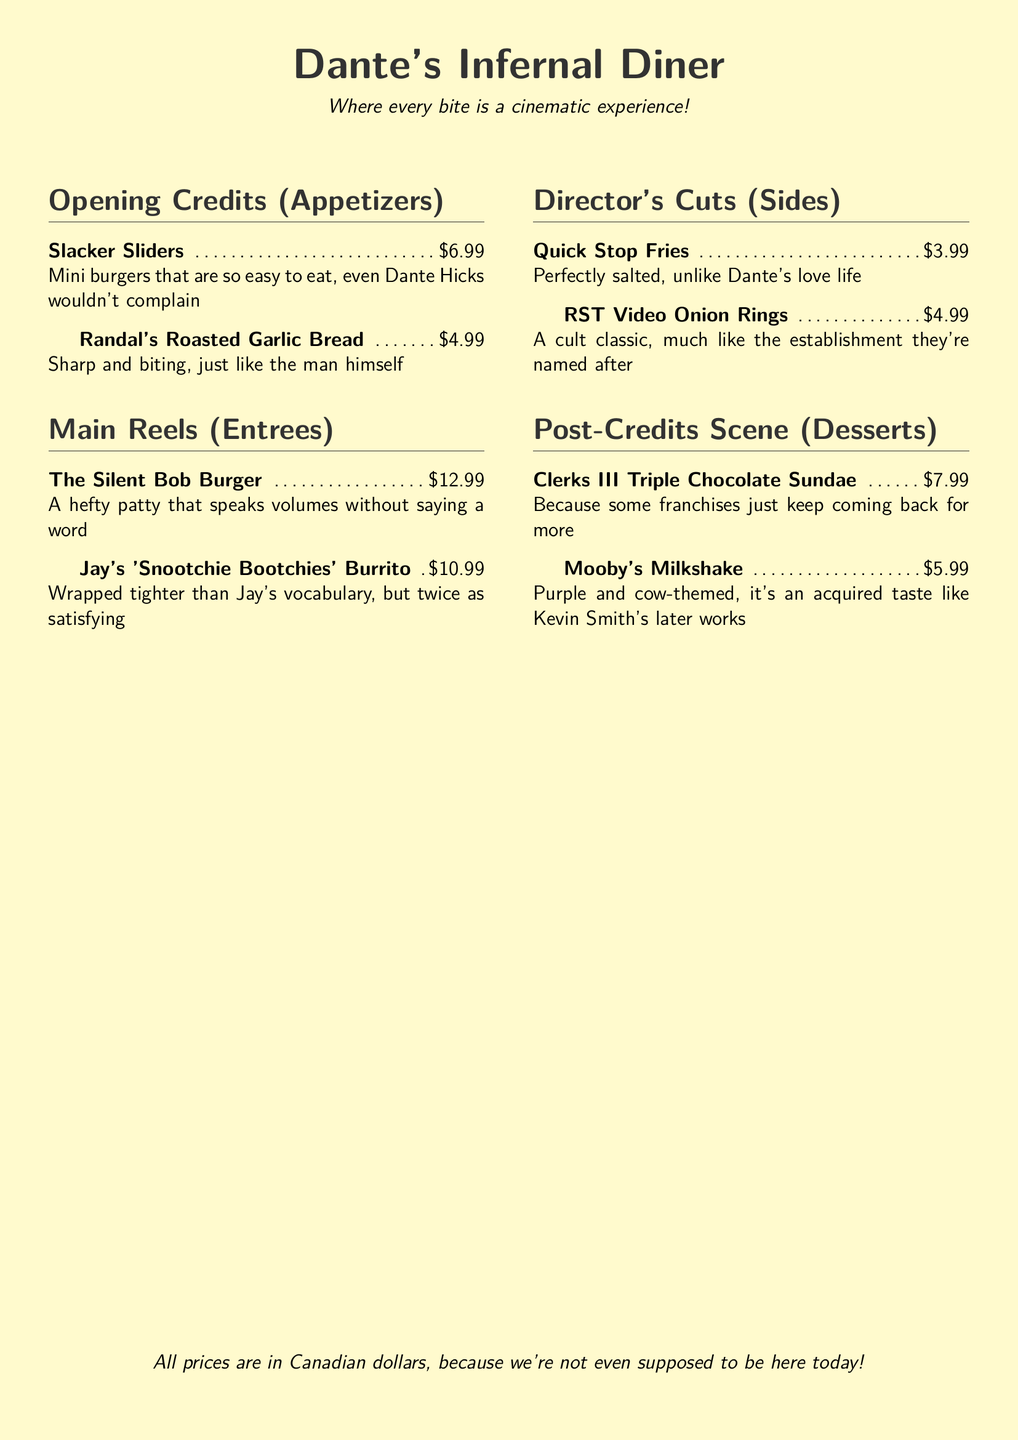What is the name of the dessert that references a sequel? The dessert named after a sequel is described as "Because some franchises just keep coming back for more."
Answer: Clerks III Triple Chocolate Sundae How much do the Quick Stop Fries cost? The price for Quick Stop Fries is listed in the menu directly.
Answer: $3.99 Which appetizer is described as being "sharp and biting"? This description directly pertains to one of the appetizers.
Answer: Randal's Roasted Garlic Bread What is the price of Jay's 'Snootchie Bootchies' Burrito? The price is stated in the menu item description for this dish.
Answer: $10.99 What type of cuisine does the menu parody? The overall theme of the menu indicates the type of cuisine being satirized.
Answer: Fast food Name one side item mentioned in the menu. The menu lists specific side items under the Director's Cuts section.
Answer: Quick Stop Fries What color theme is the diner styled in? The color theme can be inferred from the background description and document settings.
Answer: Popcorn How would you categorize the "Mooby's Milkshake"? This question prompts categorization based on the menu classification scheme used.
Answer: Dessert 